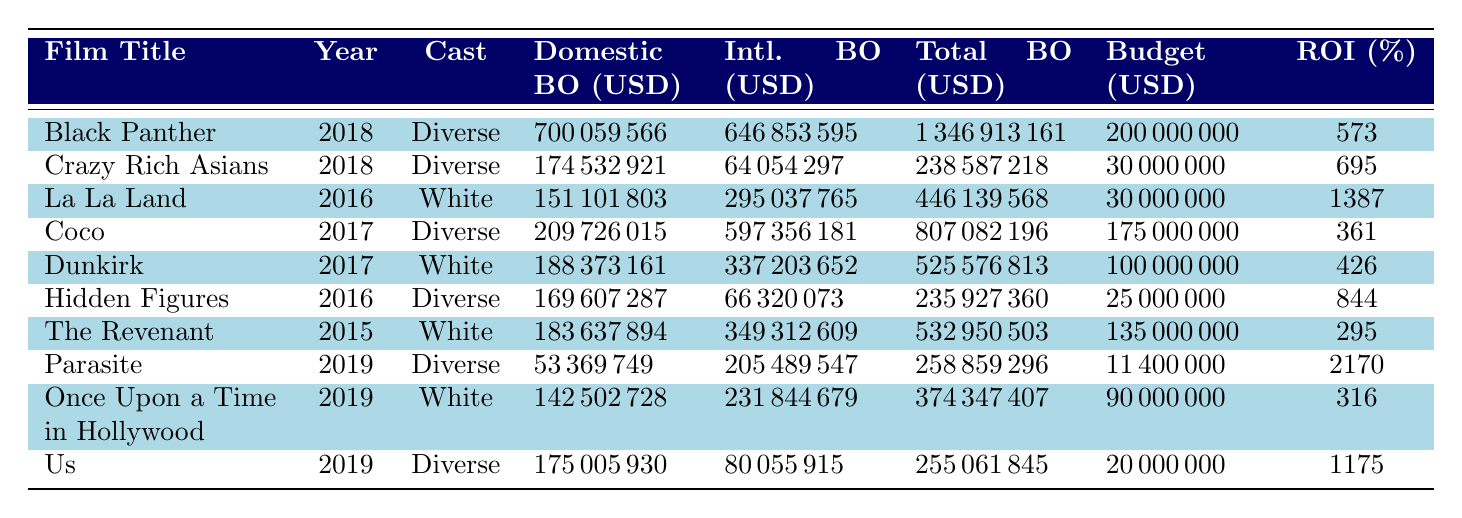What is the total box office for "Black Panther"? The total box office for "Black Panther" is shown in the table under the Total Box Office column, which indicates a total of 1,346,913,161 USD.
Answer: 1,346,913,161 USD What was the production budget for "Crazy Rich Asians"? The production budget for "Crazy Rich Asians" is listed in the Production Budget column, which indicates 30,000,000 USD.
Answer: 30,000,000 USD Which film had the highest return on investment (ROI) and what was the percentage? To determine the highest ROI, we compare the Return on Investment column. "Parasite" has the highest ROI at 2,170%.
Answer: Parasite, 2,170% What is the average total box office for the diverse cast films listed? The total box office figures for diverse cast films are: Black Panther (1,346,913,161), Crazy Rich Asians (238,587,218), Coco (807,082,196), Hidden Figures (235,927,360), Parasite (258,859,296), and Us (255,061,845). Summing these gives 3,842,571,076. Dividing by 6 films gives an average of 640,428,511.
Answer: 640,428,511 Is the domestic box office for "La La Land" greater than that of "Dunkirk"? The Domestic Box Office for "La La Land" is 151,101,803 USD, while Dunkirk's is 188,373,161 USD. Since 151,101,803 is less than 188,373,161, the answer is no.
Answer: No How much more did "Black Panther" earn at the international box office compared to "Us"? The international box office for "Black Panther" is 646,853,595 USD, while for "Us," it is 80,055,915 USD. The difference is 646,853,595 - 80,055,915 = 566,797,680 USD.
Answer: 566,797,680 USD What percentage increase in total box office does a diverse cast film have over a predominantly white cast film, on average? First, calculate the total boxes for diverse cast films (3,842,571,076) and predominantly white cast films (1,367,189,289 from La La Land, Dunkirk, The Revenant, and Once Upon a Time in Hollywood). Average for diverse cast: 640,428,511 from above; average for predominantly white: (1,367,189,289/4) = 341,797,322. The percentage increase is ((640,428,511 - 341,797,322) / 341,797,322) * 100, which equals approximately 87.59%.
Answer: 87.59% 